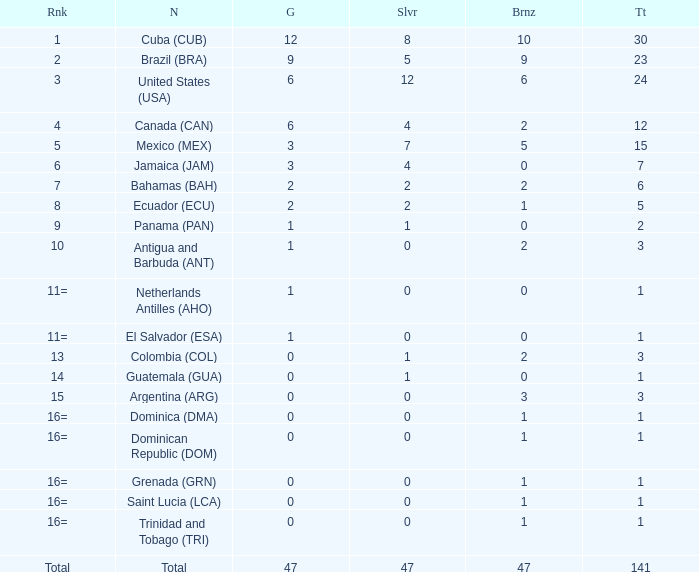What is the total gold with a total less than 1? None. 